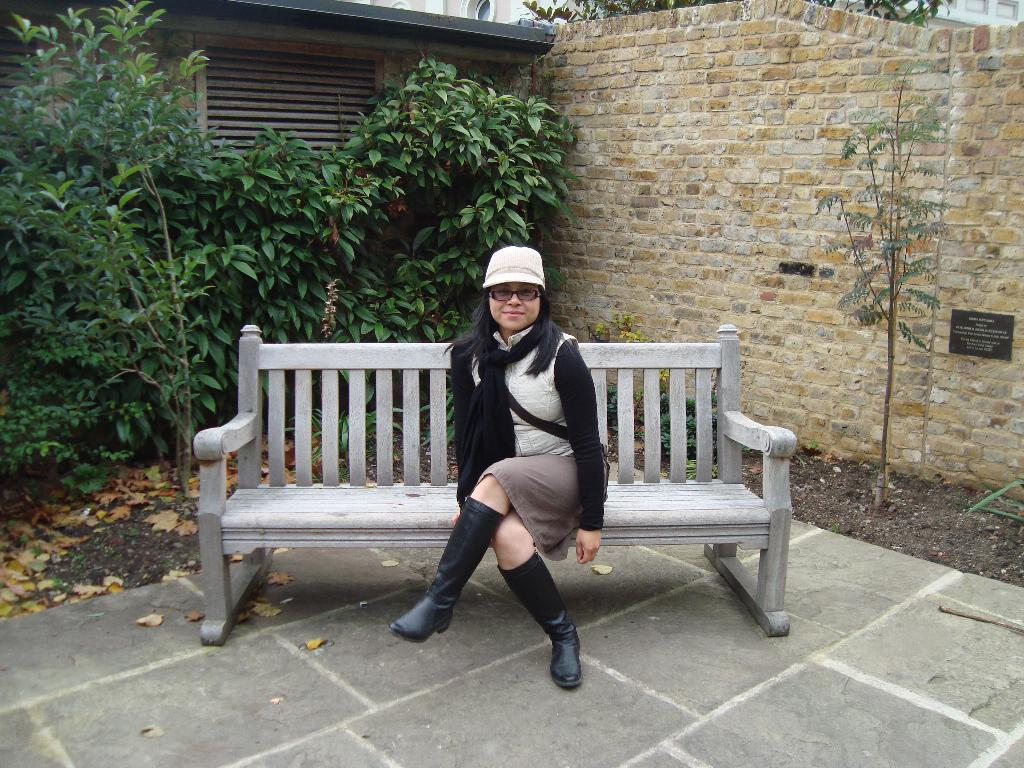Who is the main subject in the image? There is a woman in the image. What is the woman doing in the image? The woman is sitting on a bench and posing for the camera. What is the woman's facial expression in the image? The woman is smiling in the image. What can be seen in the background of the image? There are plants and a brick wall visible in the background. What type of pear is the woman holding in the image? There is no pear present in the image; the woman is sitting on a bench and posing for the camera. 